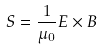<formula> <loc_0><loc_0><loc_500><loc_500>S = \frac { 1 } { \mu _ { 0 } } E \times B</formula> 